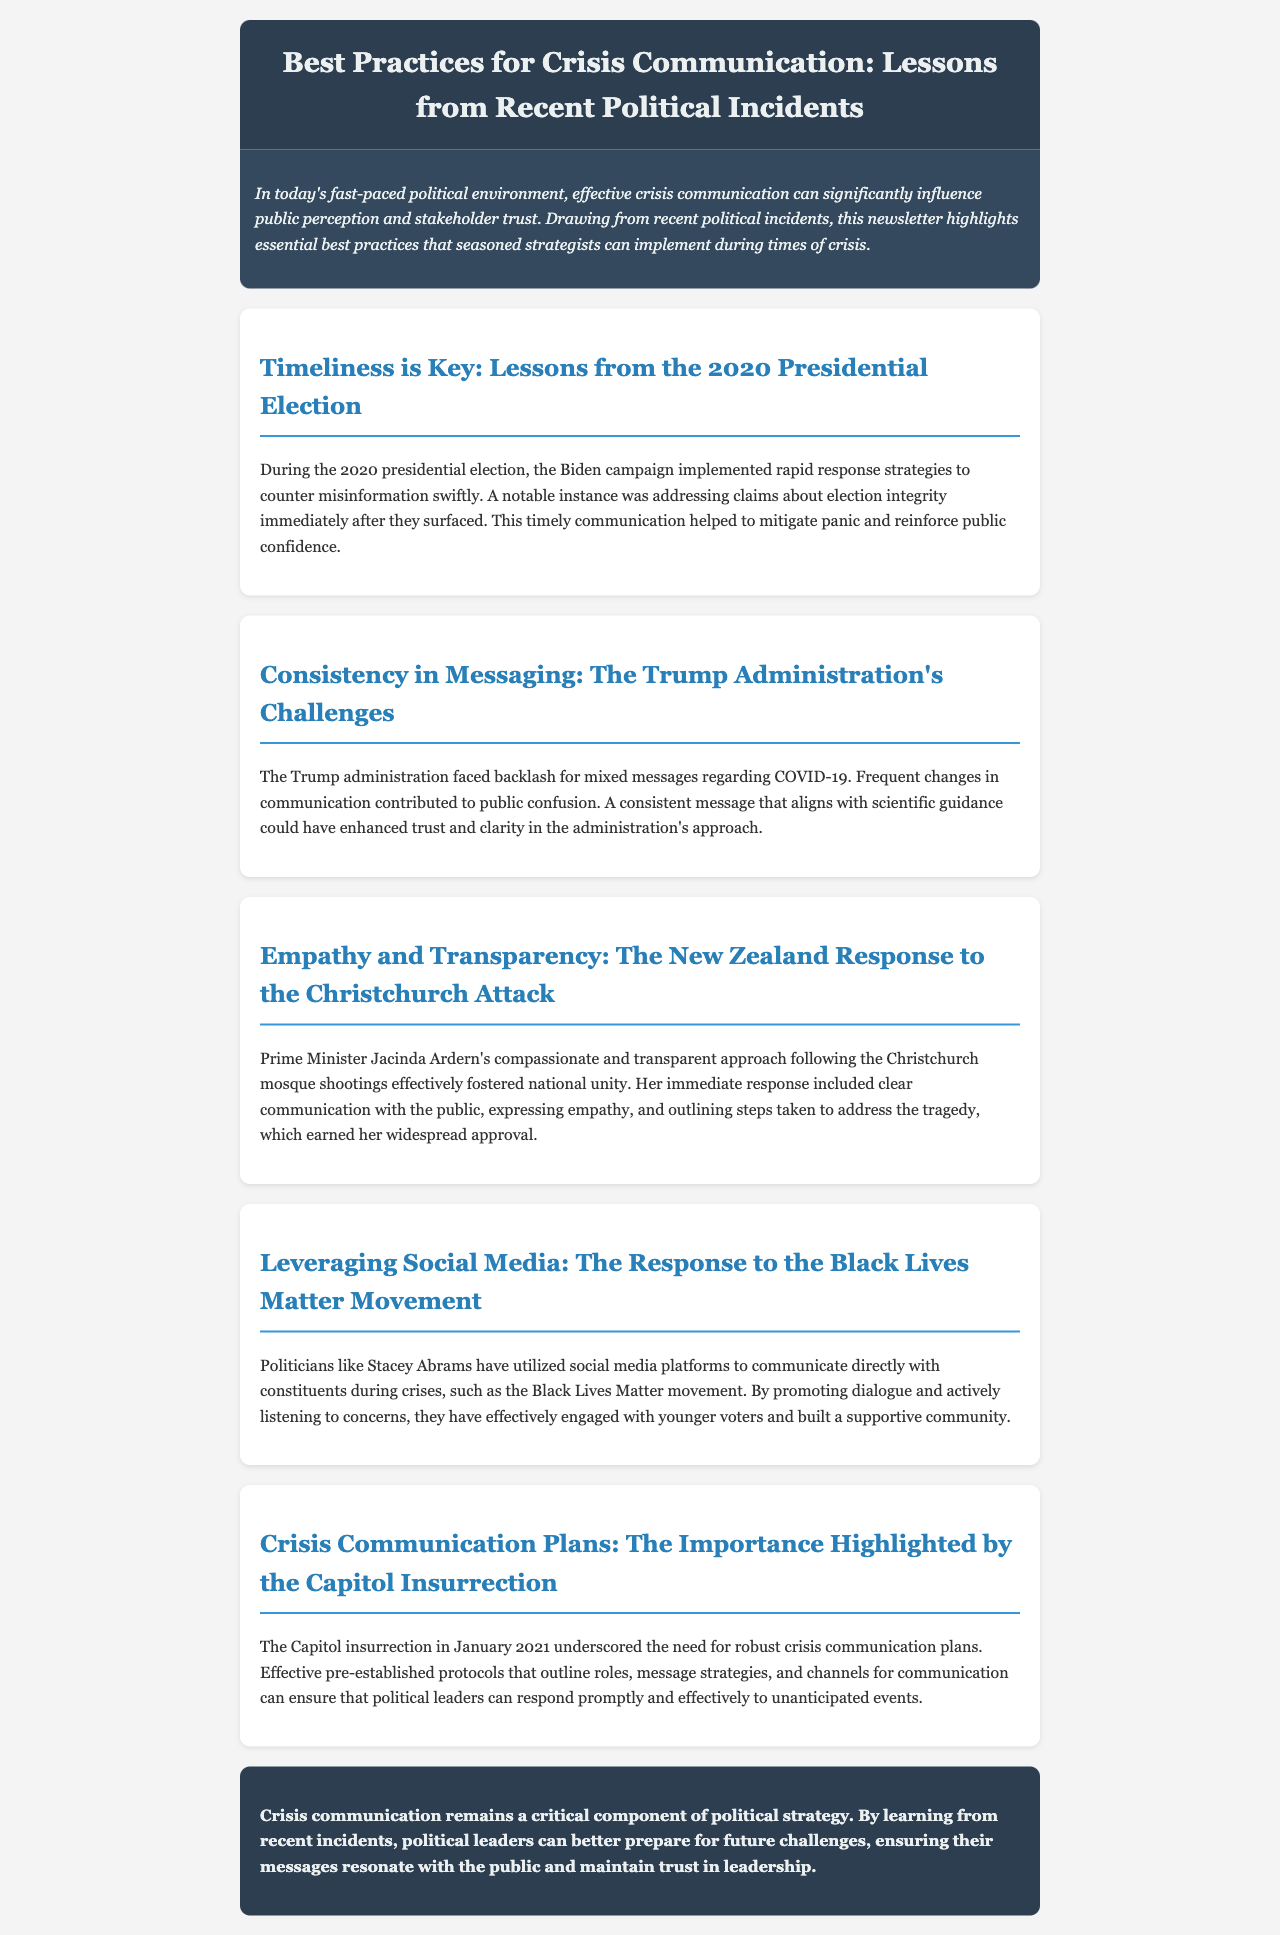What is the main topic of the newsletter? The newsletter highlights essential best practices for crisis communication drawn from recent political incidents.
Answer: Best Practices for Crisis Communication Which political event is cited for the importance of timeliness in communication? The document references the 2020 presidential election to illustrate the significance of rapid response strategies.
Answer: 2020 Presidential Election What approach did Prime Minister Jacinda Ardern take after the Christchurch attack? The newsletter states that she adopted a compassionate and transparent communication style, which contributed to national unity.
Answer: Compassionate and transparent What event highlighted the need for robust crisis communication plans? The newsletter discusses the Capitol insurrection as a crucial event that emphasized this need.
Answer: Capitol Insurrection Which individual is mentioned for effectively leveraging social media during crises? The document cites Stacey Abrams as a politician who utilized social media platforms to engage with constituents.
Answer: Stacey Abrams Explain why consistency in messaging was important for the Trump administration. The newsletter indicates that mixed messages regarding COVID-19 led to public confusion, suggesting that consistency could have enhanced trust.
Answer: Mixed messages regarding COVID-19 What does the newsletter recommend for engaging younger voters? The document suggests promoting dialogue and actively listening to concerns as methods to engage younger voters during crises.
Answer: Dialogue and listening What is the overall conclusion drawn in the newsletter? The newsletter concludes that learning from recent incidents can help political leaders prepare for future challenges in crisis communication.
Answer: Prepare for future challenges 